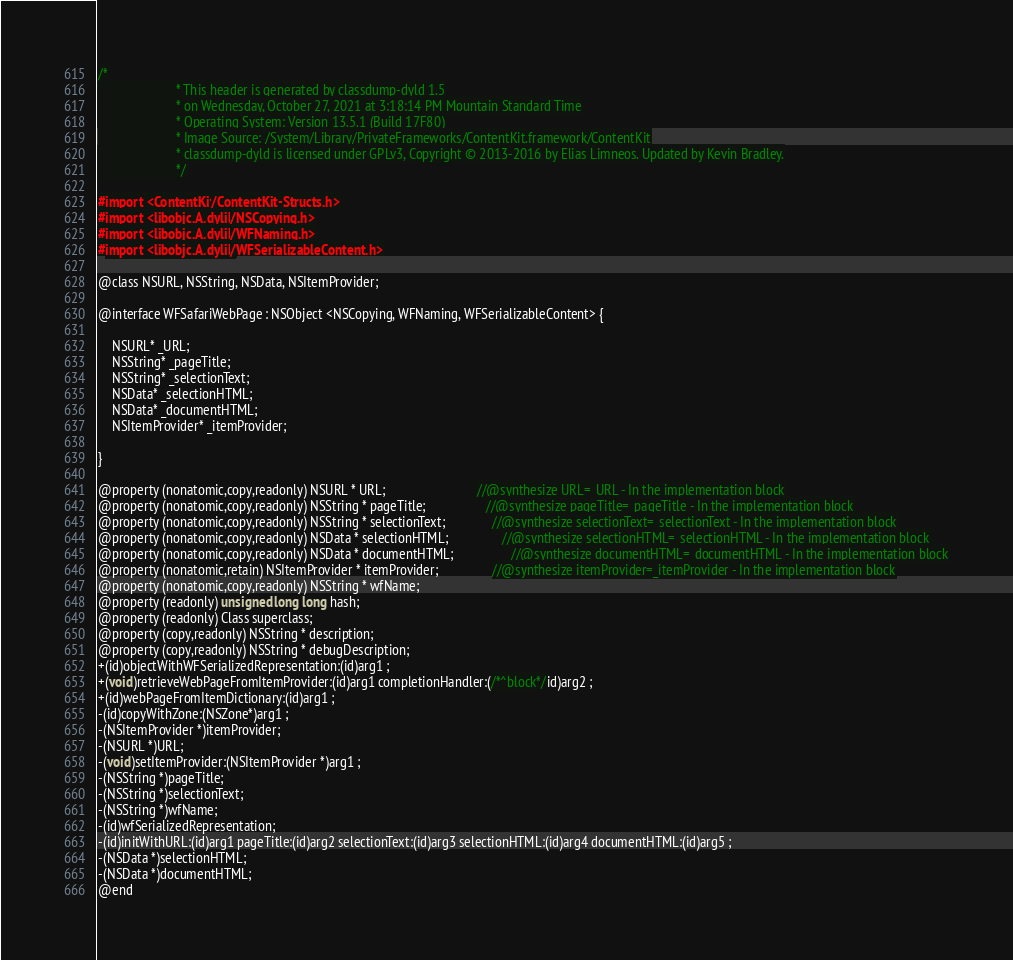Convert code to text. <code><loc_0><loc_0><loc_500><loc_500><_C_>/*
                       * This header is generated by classdump-dyld 1.5
                       * on Wednesday, October 27, 2021 at 3:18:14 PM Mountain Standard Time
                       * Operating System: Version 13.5.1 (Build 17F80)
                       * Image Source: /System/Library/PrivateFrameworks/ContentKit.framework/ContentKit
                       * classdump-dyld is licensed under GPLv3, Copyright © 2013-2016 by Elias Limneos. Updated by Kevin Bradley.
                       */

#import <ContentKit/ContentKit-Structs.h>
#import <libobjc.A.dylib/NSCopying.h>
#import <libobjc.A.dylib/WFNaming.h>
#import <libobjc.A.dylib/WFSerializableContent.h>

@class NSURL, NSString, NSData, NSItemProvider;

@interface WFSafariWebPage : NSObject <NSCopying, WFNaming, WFSerializableContent> {

	NSURL* _URL;
	NSString* _pageTitle;
	NSString* _selectionText;
	NSData* _selectionHTML;
	NSData* _documentHTML;
	NSItemProvider* _itemProvider;

}

@property (nonatomic,copy,readonly) NSURL * URL;                           //@synthesize URL=_URL - In the implementation block
@property (nonatomic,copy,readonly) NSString * pageTitle;                  //@synthesize pageTitle=_pageTitle - In the implementation block
@property (nonatomic,copy,readonly) NSString * selectionText;              //@synthesize selectionText=_selectionText - In the implementation block
@property (nonatomic,copy,readonly) NSData * selectionHTML;                //@synthesize selectionHTML=_selectionHTML - In the implementation block
@property (nonatomic,copy,readonly) NSData * documentHTML;                 //@synthesize documentHTML=_documentHTML - In the implementation block
@property (nonatomic,retain) NSItemProvider * itemProvider;                //@synthesize itemProvider=_itemProvider - In the implementation block
@property (nonatomic,copy,readonly) NSString * wfName; 
@property (readonly) unsigned long long hash; 
@property (readonly) Class superclass; 
@property (copy,readonly) NSString * description; 
@property (copy,readonly) NSString * debugDescription; 
+(id)objectWithWFSerializedRepresentation:(id)arg1 ;
+(void)retrieveWebPageFromItemProvider:(id)arg1 completionHandler:(/*^block*/id)arg2 ;
+(id)webPageFromItemDictionary:(id)arg1 ;
-(id)copyWithZone:(NSZone*)arg1 ;
-(NSItemProvider *)itemProvider;
-(NSURL *)URL;
-(void)setItemProvider:(NSItemProvider *)arg1 ;
-(NSString *)pageTitle;
-(NSString *)selectionText;
-(NSString *)wfName;
-(id)wfSerializedRepresentation;
-(id)initWithURL:(id)arg1 pageTitle:(id)arg2 selectionText:(id)arg3 selectionHTML:(id)arg4 documentHTML:(id)arg5 ;
-(NSData *)selectionHTML;
-(NSData *)documentHTML;
@end

</code> 